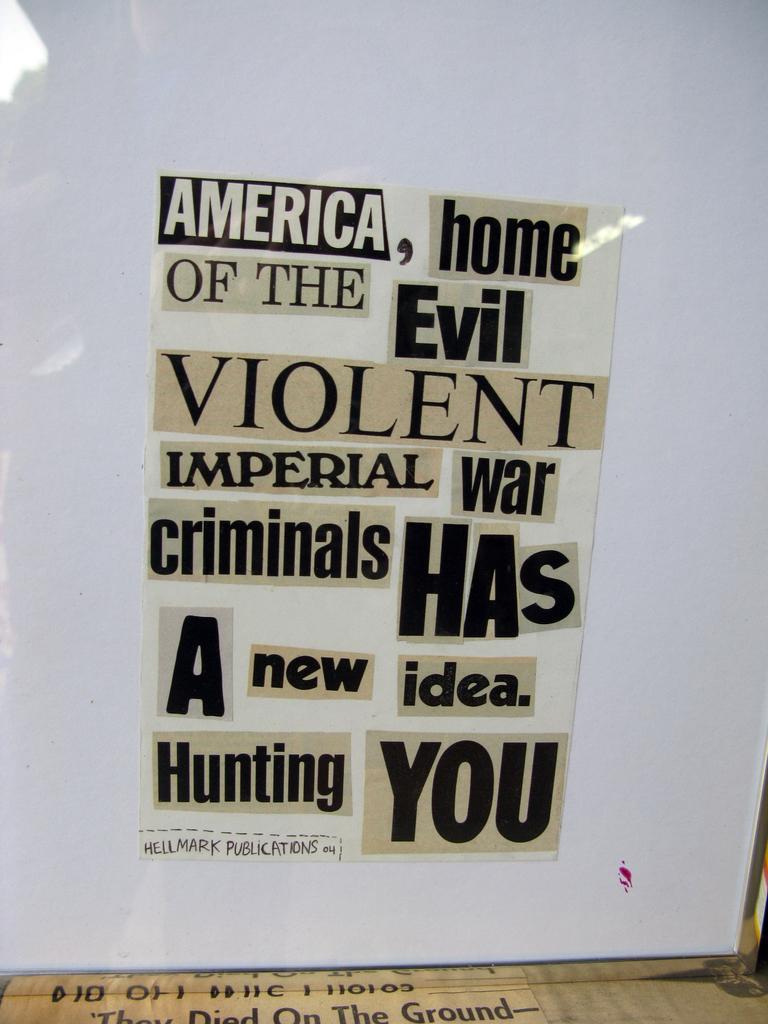What are the war criminals hunting for?
Provide a short and direct response. You. 